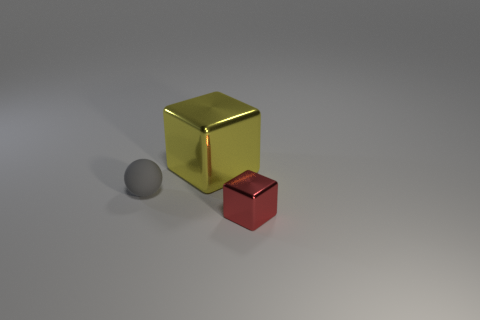What can you tell me about the lighting in the scene? The lighting in the image seems to come from a high angle, possibly from above and to the right, considering how the shadows are being cast. The source is likely diffuse, softening the shadows. The tones and shadows suggest a controlled environment, indicative of indoor lighting possibly designed to simulate a natural soft light ambiance. 